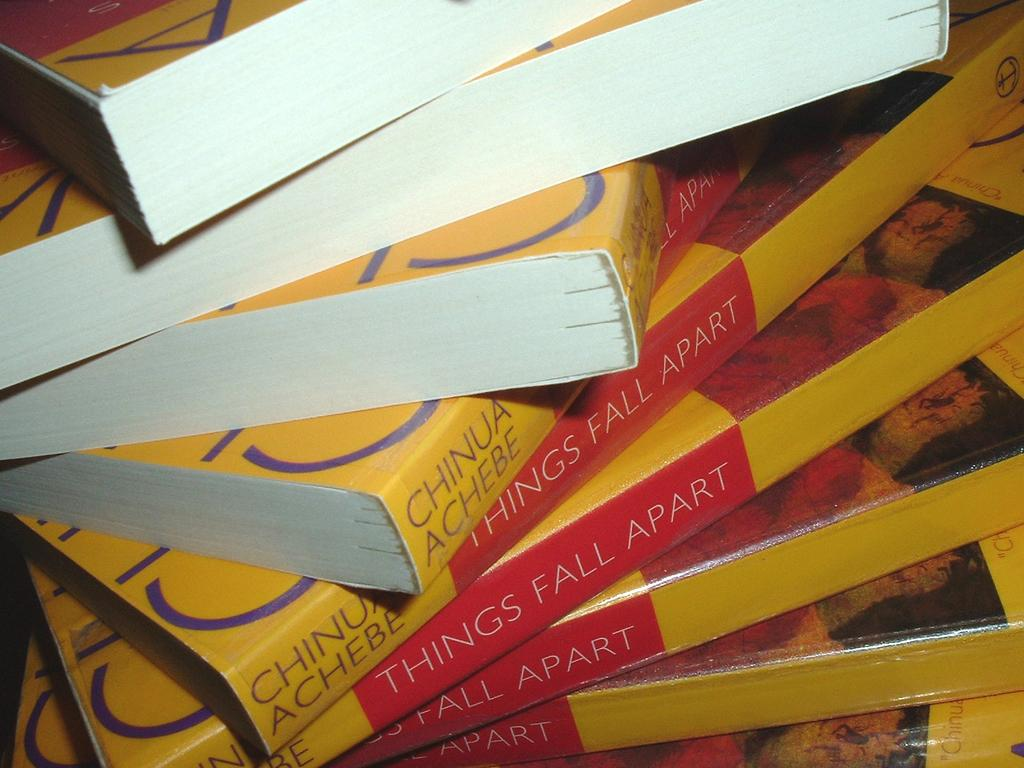<image>
Write a terse but informative summary of the picture. A number of the same book laying on their side titled Things Fall Apart. 